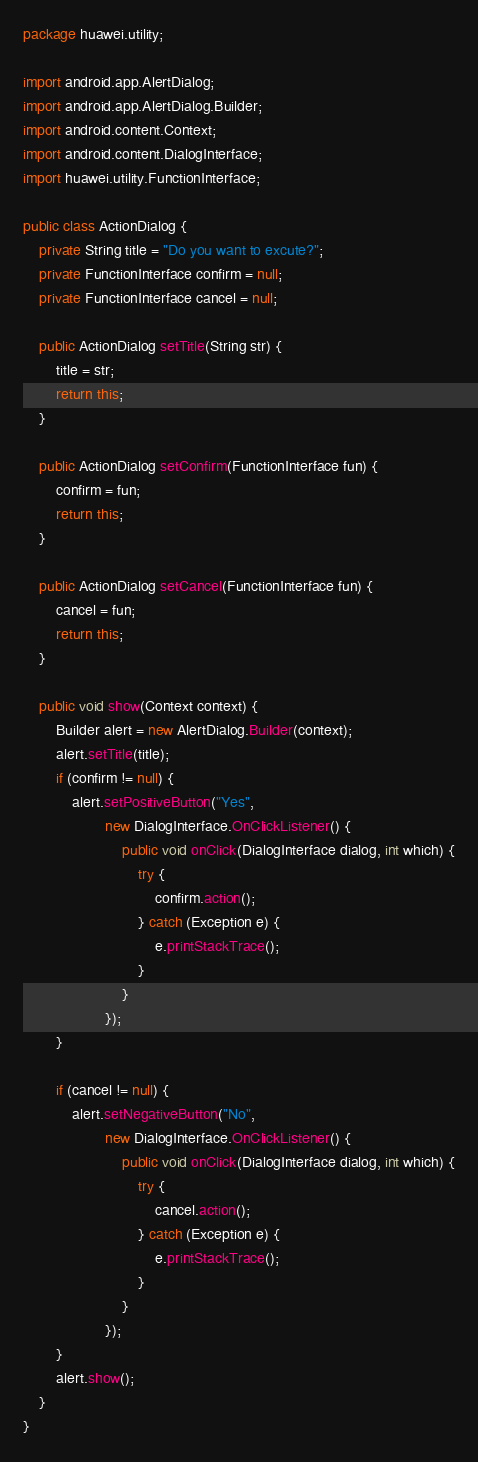<code> <loc_0><loc_0><loc_500><loc_500><_Java_>package huawei.utility;

import android.app.AlertDialog;
import android.app.AlertDialog.Builder;
import android.content.Context;
import android.content.DialogInterface;
import huawei.utility.FunctionInterface;

public class ActionDialog {
	private String title = "Do you want to excute?";
	private FunctionInterface confirm = null;
	private FunctionInterface cancel = null;

	public ActionDialog setTitle(String str) {
		title = str;
		return this;
	}

	public ActionDialog setConfirm(FunctionInterface fun) {
		confirm = fun;
		return this;
	}

	public ActionDialog setCancel(FunctionInterface fun) {
		cancel = fun;
		return this;
	}

	public void show(Context context) {
		Builder alert = new AlertDialog.Builder(context);
		alert.setTitle(title);
		if (confirm != null) {
			alert.setPositiveButton("Yes",
					new DialogInterface.OnClickListener() {
						public void onClick(DialogInterface dialog, int which) {
							try {
								confirm.action();
							} catch (Exception e) {
								e.printStackTrace();
							}
						}
					});
		}

		if (cancel != null) {
			alert.setNegativeButton("No",
					new DialogInterface.OnClickListener() {
						public void onClick(DialogInterface dialog, int which) {
							try {
								cancel.action();
							} catch (Exception e) {
								e.printStackTrace();
							}
						}
					});
		}
		alert.show();
	}
}
</code> 